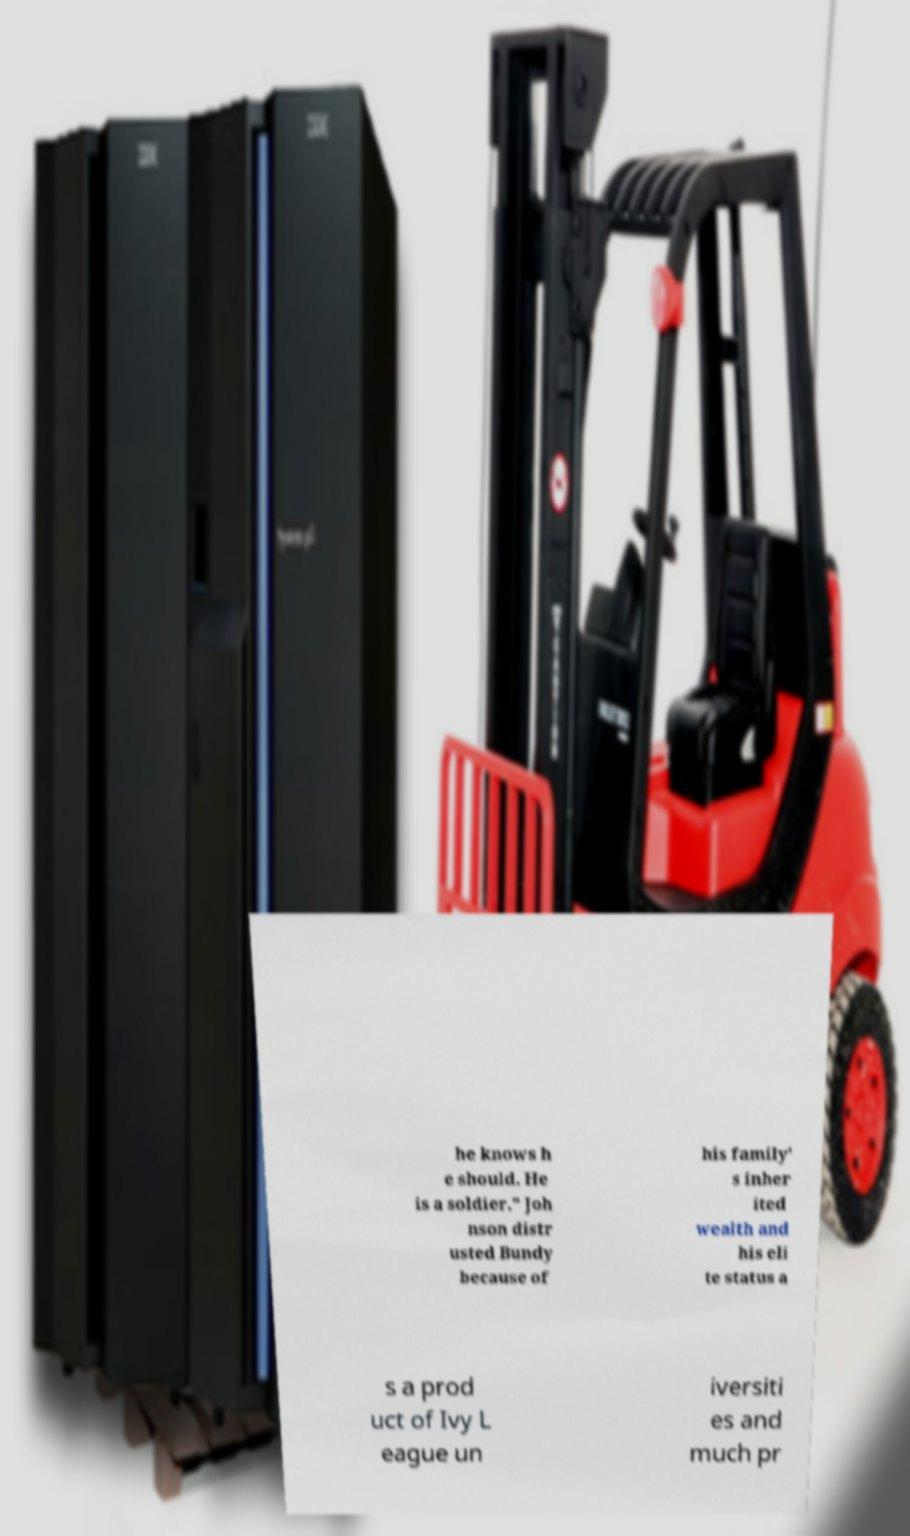Can you read and provide the text displayed in the image?This photo seems to have some interesting text. Can you extract and type it out for me? he knows h e should. He is a soldier." Joh nson distr usted Bundy because of his family' s inher ited wealth and his eli te status a s a prod uct of Ivy L eague un iversiti es and much pr 